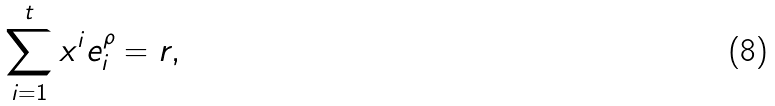Convert formula to latex. <formula><loc_0><loc_0><loc_500><loc_500>\sum _ { i = 1 } ^ { t } x ^ { i } e _ { i } ^ { \rho } = r ,</formula> 